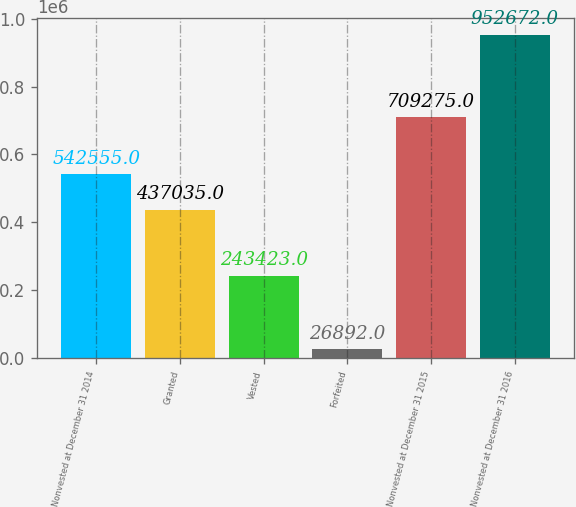Convert chart. <chart><loc_0><loc_0><loc_500><loc_500><bar_chart><fcel>Nonvested at December 31 2014<fcel>Granted<fcel>Vested<fcel>Forfeited<fcel>Nonvested at December 31 2015<fcel>Nonvested at December 31 2016<nl><fcel>542555<fcel>437035<fcel>243423<fcel>26892<fcel>709275<fcel>952672<nl></chart> 